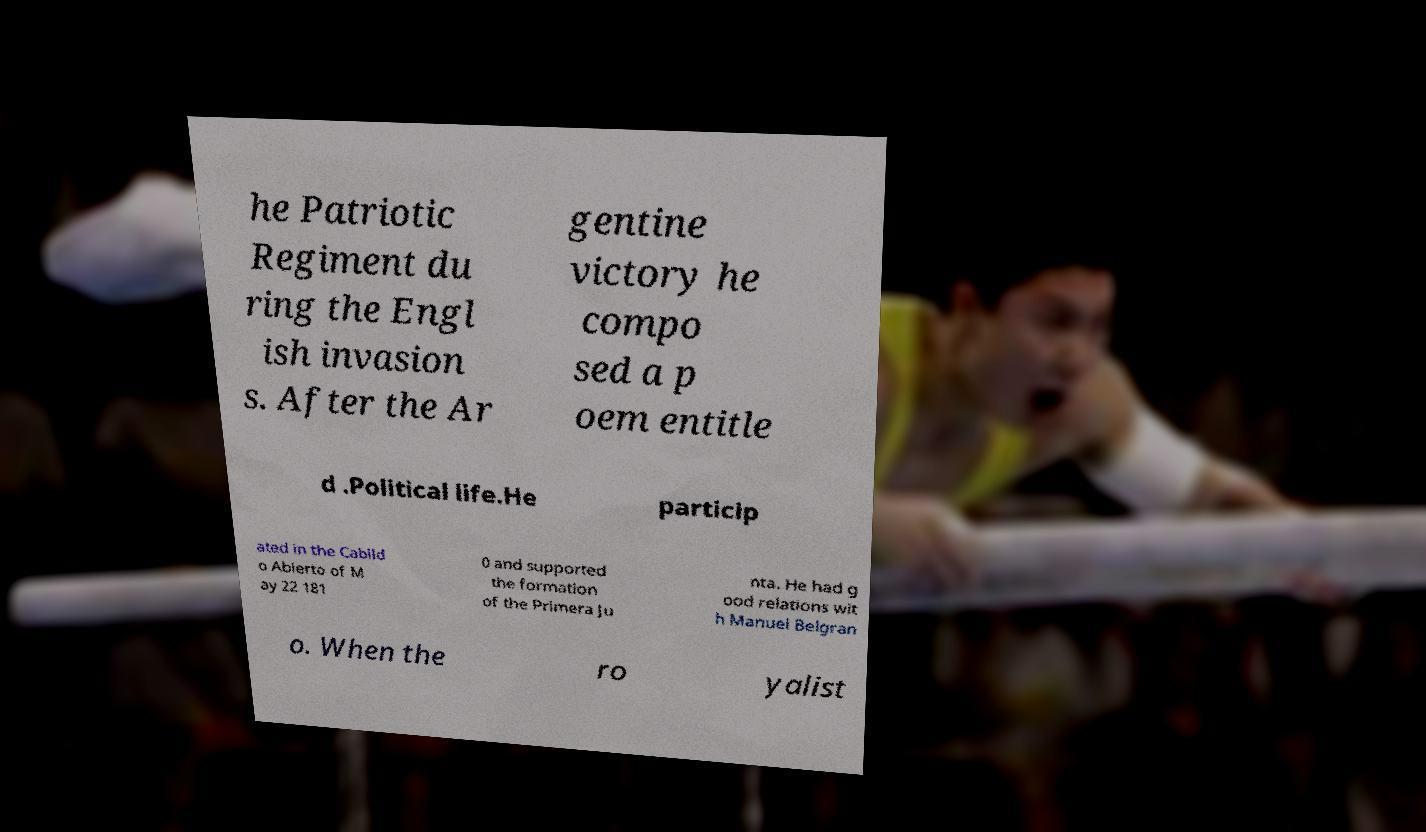Can you accurately transcribe the text from the provided image for me? he Patriotic Regiment du ring the Engl ish invasion s. After the Ar gentine victory he compo sed a p oem entitle d .Political life.He particip ated in the Cabild o Abierto of M ay 22 181 0 and supported the formation of the Primera Ju nta. He had g ood relations wit h Manuel Belgran o. When the ro yalist 